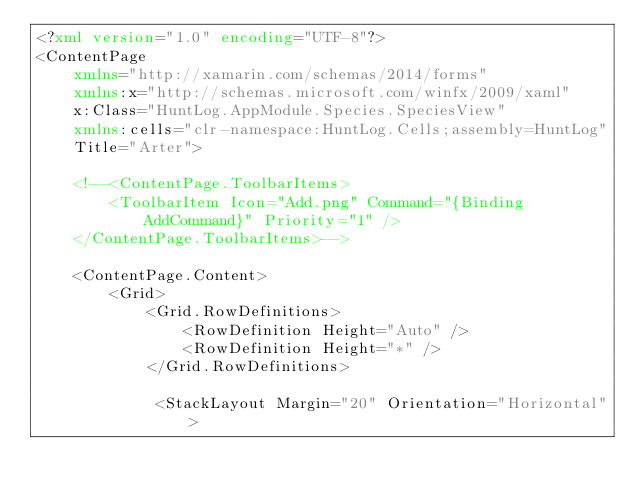<code> <loc_0><loc_0><loc_500><loc_500><_XML_><?xml version="1.0" encoding="UTF-8"?>
<ContentPage 
    xmlns="http://xamarin.com/schemas/2014/forms" 
    xmlns:x="http://schemas.microsoft.com/winfx/2009/xaml" 
    x:Class="HuntLog.AppModule.Species.SpeciesView"
    xmlns:cells="clr-namespace:HuntLog.Cells;assembly=HuntLog"
    Title="Arter">
     
    <!--<ContentPage.ToolbarItems>
        <ToolbarItem Icon="Add.png" Command="{Binding AddCommand}" Priority="1" />
    </ContentPage.ToolbarItems>-->
    
    <ContentPage.Content>
        <Grid>
            <Grid.RowDefinitions>
                <RowDefinition Height="Auto" />
                <RowDefinition Height="*" />
            </Grid.RowDefinitions>
            
             <StackLayout Margin="20" Orientation="Horizontal"></code> 